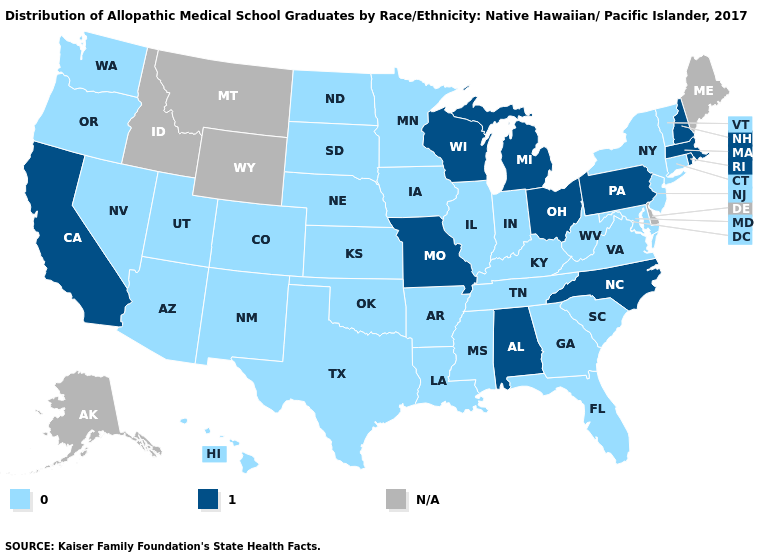Name the states that have a value in the range N/A?
Keep it brief. Alaska, Delaware, Idaho, Maine, Montana, Wyoming. What is the value of Oregon?
Concise answer only. 0.0. Does the map have missing data?
Answer briefly. Yes. What is the value of Massachusetts?
Concise answer only. 1.0. Does North Carolina have the highest value in the USA?
Quick response, please. Yes. Does New Hampshire have the lowest value in the Northeast?
Concise answer only. No. Which states have the lowest value in the USA?
Give a very brief answer. Arizona, Arkansas, Colorado, Connecticut, Florida, Georgia, Hawaii, Illinois, Indiana, Iowa, Kansas, Kentucky, Louisiana, Maryland, Minnesota, Mississippi, Nebraska, Nevada, New Jersey, New Mexico, New York, North Dakota, Oklahoma, Oregon, South Carolina, South Dakota, Tennessee, Texas, Utah, Vermont, Virginia, Washington, West Virginia. What is the lowest value in states that border South Dakota?
Keep it brief. 0.0. Does Wisconsin have the lowest value in the USA?
Write a very short answer. No. Is the legend a continuous bar?
Be succinct. No. Name the states that have a value in the range 1.0?
Answer briefly. Alabama, California, Massachusetts, Michigan, Missouri, New Hampshire, North Carolina, Ohio, Pennsylvania, Rhode Island, Wisconsin. Among the states that border Mississippi , which have the highest value?
Write a very short answer. Alabama. What is the value of West Virginia?
Keep it brief. 0.0. Does the map have missing data?
Short answer required. Yes. 